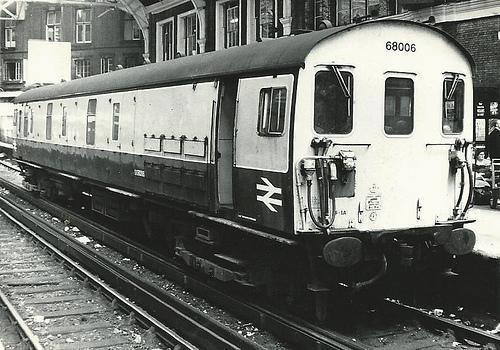How many trains are in the photo?
Give a very brief answer. 1. 